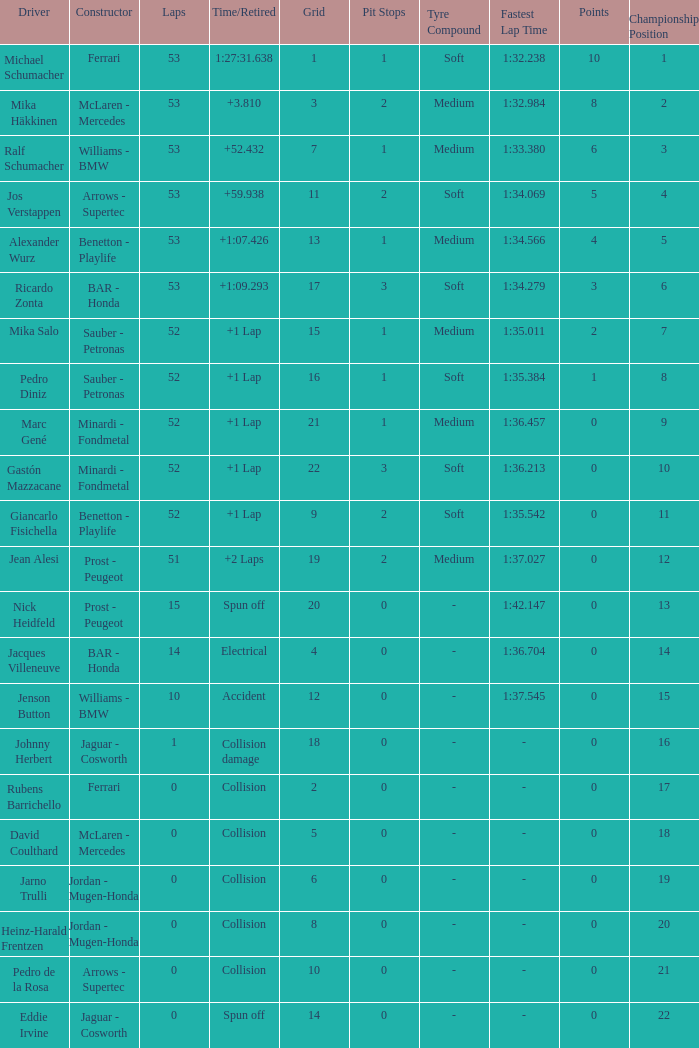Could you parse the entire table as a dict? {'header': ['Driver', 'Constructor', 'Laps', 'Time/Retired', 'Grid', 'Pit Stops', 'Tyre Compound', 'Fastest Lap Time', 'Points', 'Championship Position'], 'rows': [['Michael Schumacher', 'Ferrari', '53', '1:27:31.638', '1', '1', 'Soft', '1:32.238', '10', '1'], ['Mika Häkkinen', 'McLaren - Mercedes', '53', '+3.810', '3', '2', 'Medium', '1:32.984', '8', '2'], ['Ralf Schumacher', 'Williams - BMW', '53', '+52.432', '7', '1', 'Medium', '1:33.380', '6', '3'], ['Jos Verstappen', 'Arrows - Supertec', '53', '+59.938', '11', '2', 'Soft', '1:34.069', '5', '4'], ['Alexander Wurz', 'Benetton - Playlife', '53', '+1:07.426', '13', '1', 'Medium', '1:34.566', '4', '5'], ['Ricardo Zonta', 'BAR - Honda', '53', '+1:09.293', '17', '3', 'Soft', '1:34.279', '3', '6'], ['Mika Salo', 'Sauber - Petronas', '52', '+1 Lap', '15', '1', 'Medium', '1:35.011', '2', '7'], ['Pedro Diniz', 'Sauber - Petronas', '52', '+1 Lap', '16', '1', 'Soft', '1:35.384', '1', '8'], ['Marc Gené', 'Minardi - Fondmetal', '52', '+1 Lap', '21', '1', 'Medium', '1:36.457', '0', '9'], ['Gastón Mazzacane', 'Minardi - Fondmetal', '52', '+1 Lap', '22', '3', 'Soft', '1:36.213', '0', '10'], ['Giancarlo Fisichella', 'Benetton - Playlife', '52', '+1 Lap', '9', '2', 'Soft', '1:35.542', '0', '11'], ['Jean Alesi', 'Prost - Peugeot', '51', '+2 Laps', '19', '2', 'Medium', '1:37.027', '0', '12'], ['Nick Heidfeld', 'Prost - Peugeot', '15', 'Spun off', '20', '0', '-', '1:42.147', '0', '13'], ['Jacques Villeneuve', 'BAR - Honda', '14', 'Electrical', '4', '0', '-', '1:36.704', '0', '14'], ['Jenson Button', 'Williams - BMW', '10', 'Accident', '12', '0', '-', '1:37.545', '0', '15'], ['Johnny Herbert', 'Jaguar - Cosworth', '1', 'Collision damage', '18', '0', '-', '-', '0', '16'], ['Rubens Barrichello', 'Ferrari', '0', 'Collision', '2', '0', '-', '-', '0', '17'], ['David Coulthard', 'McLaren - Mercedes', '0', 'Collision', '5', '0', '-', '-', '0', '18'], ['Jarno Trulli', 'Jordan - Mugen-Honda', '0', 'Collision', '6', '0', '-', '-', '0', '19'], ['Heinz-Harald Frentzen', 'Jordan - Mugen-Honda', '0', 'Collision', '8', '0', '-', '-', '0', '20'], ['Pedro de la Rosa', 'Arrows - Supertec', '0', 'Collision', '10', '0', '-', '-', '0', '21'], ['Eddie Irvine', 'Jaguar - Cosworth', '0', 'Spun off', '14', '0', '-', '-', '0', '22']]} What is the grid number with less than 52 laps and a Time/Retired of collision, and a Constructor of arrows - supertec? 1.0. 